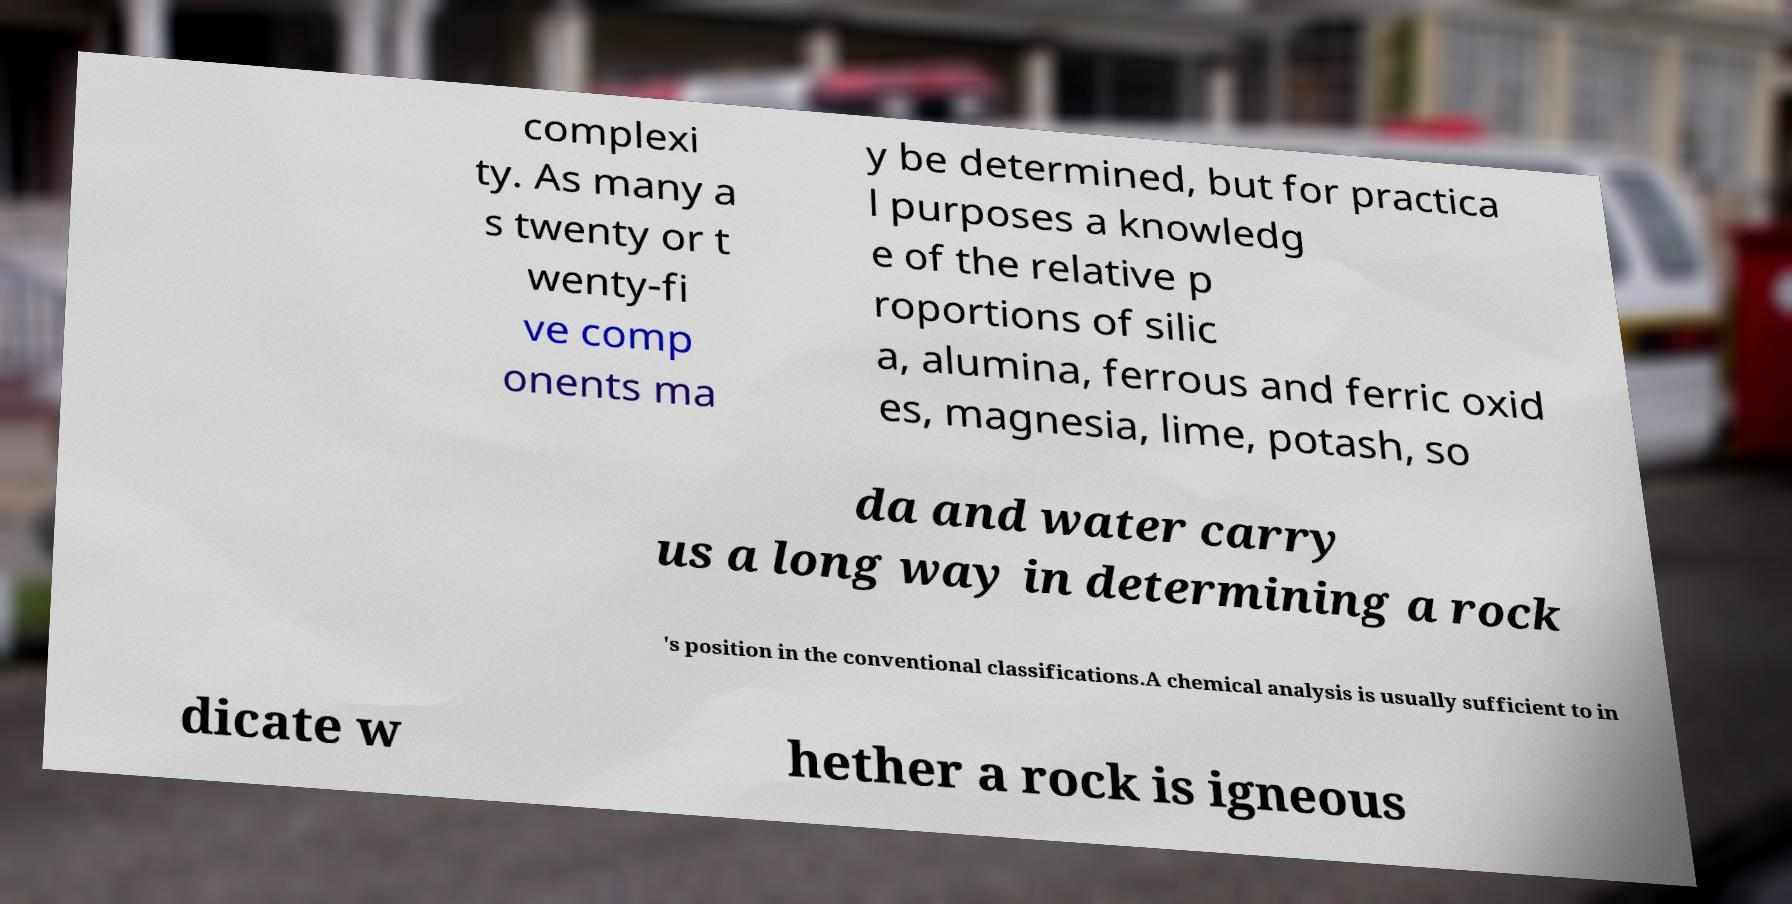I need the written content from this picture converted into text. Can you do that? complexi ty. As many a s twenty or t wenty-fi ve comp onents ma y be determined, but for practica l purposes a knowledg e of the relative p roportions of silic a, alumina, ferrous and ferric oxid es, magnesia, lime, potash, so da and water carry us a long way in determining a rock 's position in the conventional classifications.A chemical analysis is usually sufficient to in dicate w hether a rock is igneous 